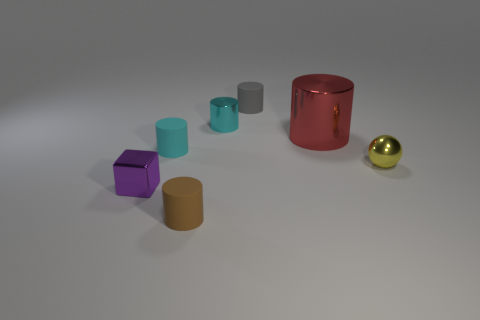Subtract all gray cylinders. How many cylinders are left? 4 Subtract all cyan balls. How many cyan cylinders are left? 2 Subtract all brown cylinders. How many cylinders are left? 4 Add 2 small yellow matte balls. How many objects exist? 9 Subtract all cylinders. How many objects are left? 2 Subtract all brown cylinders. Subtract all purple spheres. How many cylinders are left? 4 Subtract all purple metal cubes. Subtract all tiny shiny objects. How many objects are left? 3 Add 7 brown rubber things. How many brown rubber things are left? 8 Add 7 large rubber spheres. How many large rubber spheres exist? 7 Subtract 0 blue spheres. How many objects are left? 7 